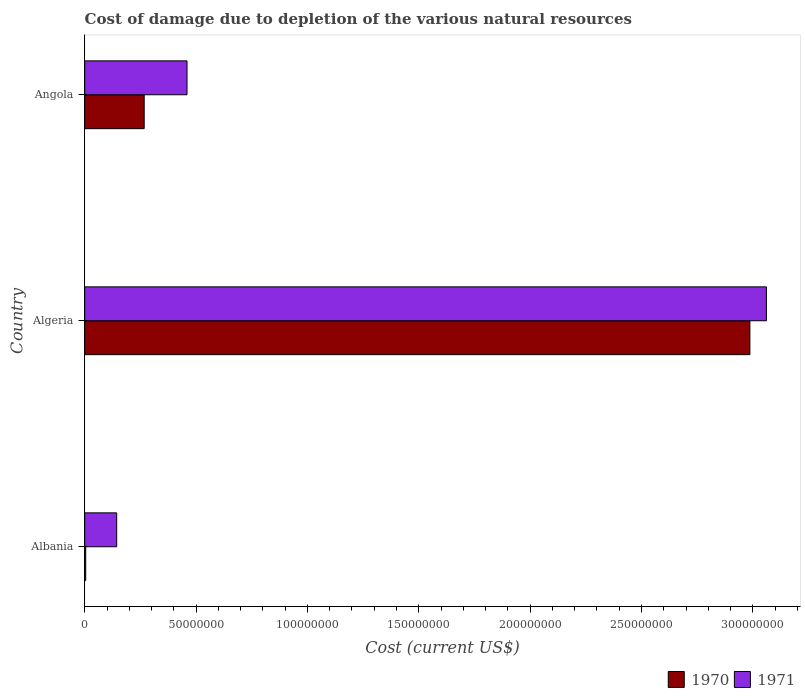How many groups of bars are there?
Your answer should be compact. 3. Are the number of bars per tick equal to the number of legend labels?
Give a very brief answer. Yes. What is the label of the 2nd group of bars from the top?
Ensure brevity in your answer.  Algeria. In how many cases, is the number of bars for a given country not equal to the number of legend labels?
Provide a succinct answer. 0. What is the cost of damage caused due to the depletion of various natural resources in 1970 in Angola?
Your response must be concise. 2.67e+07. Across all countries, what is the maximum cost of damage caused due to the depletion of various natural resources in 1970?
Your answer should be compact. 2.99e+08. Across all countries, what is the minimum cost of damage caused due to the depletion of various natural resources in 1971?
Provide a succinct answer. 1.44e+07. In which country was the cost of damage caused due to the depletion of various natural resources in 1970 maximum?
Ensure brevity in your answer.  Algeria. In which country was the cost of damage caused due to the depletion of various natural resources in 1971 minimum?
Give a very brief answer. Albania. What is the total cost of damage caused due to the depletion of various natural resources in 1971 in the graph?
Offer a very short reply. 3.66e+08. What is the difference between the cost of damage caused due to the depletion of various natural resources in 1970 in Algeria and that in Angola?
Give a very brief answer. 2.72e+08. What is the difference between the cost of damage caused due to the depletion of various natural resources in 1970 in Angola and the cost of damage caused due to the depletion of various natural resources in 1971 in Algeria?
Make the answer very short. -2.79e+08. What is the average cost of damage caused due to the depletion of various natural resources in 1971 per country?
Offer a very short reply. 1.22e+08. What is the difference between the cost of damage caused due to the depletion of various natural resources in 1970 and cost of damage caused due to the depletion of various natural resources in 1971 in Algeria?
Offer a terse response. -7.42e+06. In how many countries, is the cost of damage caused due to the depletion of various natural resources in 1970 greater than 170000000 US$?
Offer a very short reply. 1. What is the ratio of the cost of damage caused due to the depletion of various natural resources in 1970 in Albania to that in Angola?
Make the answer very short. 0.02. Is the cost of damage caused due to the depletion of various natural resources in 1970 in Albania less than that in Angola?
Your response must be concise. Yes. What is the difference between the highest and the second highest cost of damage caused due to the depletion of various natural resources in 1971?
Provide a short and direct response. 2.60e+08. What is the difference between the highest and the lowest cost of damage caused due to the depletion of various natural resources in 1971?
Provide a short and direct response. 2.92e+08. In how many countries, is the cost of damage caused due to the depletion of various natural resources in 1970 greater than the average cost of damage caused due to the depletion of various natural resources in 1970 taken over all countries?
Offer a very short reply. 1. What does the 2nd bar from the bottom in Angola represents?
Make the answer very short. 1971. Are all the bars in the graph horizontal?
Your answer should be very brief. Yes. How many countries are there in the graph?
Provide a succinct answer. 3. What is the difference between two consecutive major ticks on the X-axis?
Your answer should be compact. 5.00e+07. Does the graph contain any zero values?
Provide a short and direct response. No. Does the graph contain grids?
Provide a succinct answer. No. Where does the legend appear in the graph?
Your answer should be compact. Bottom right. What is the title of the graph?
Provide a short and direct response. Cost of damage due to depletion of the various natural resources. Does "2011" appear as one of the legend labels in the graph?
Ensure brevity in your answer.  No. What is the label or title of the X-axis?
Give a very brief answer. Cost (current US$). What is the Cost (current US$) in 1970 in Albania?
Keep it short and to the point. 4.39e+05. What is the Cost (current US$) of 1971 in Albania?
Your response must be concise. 1.44e+07. What is the Cost (current US$) in 1970 in Algeria?
Offer a terse response. 2.99e+08. What is the Cost (current US$) in 1971 in Algeria?
Offer a very short reply. 3.06e+08. What is the Cost (current US$) in 1970 in Angola?
Ensure brevity in your answer.  2.67e+07. What is the Cost (current US$) in 1971 in Angola?
Keep it short and to the point. 4.59e+07. Across all countries, what is the maximum Cost (current US$) of 1970?
Provide a short and direct response. 2.99e+08. Across all countries, what is the maximum Cost (current US$) of 1971?
Offer a very short reply. 3.06e+08. Across all countries, what is the minimum Cost (current US$) of 1970?
Make the answer very short. 4.39e+05. Across all countries, what is the minimum Cost (current US$) of 1971?
Give a very brief answer. 1.44e+07. What is the total Cost (current US$) of 1970 in the graph?
Give a very brief answer. 3.26e+08. What is the total Cost (current US$) in 1971 in the graph?
Provide a succinct answer. 3.66e+08. What is the difference between the Cost (current US$) of 1970 in Albania and that in Algeria?
Offer a terse response. -2.98e+08. What is the difference between the Cost (current US$) of 1971 in Albania and that in Algeria?
Ensure brevity in your answer.  -2.92e+08. What is the difference between the Cost (current US$) in 1970 in Albania and that in Angola?
Offer a terse response. -2.63e+07. What is the difference between the Cost (current US$) in 1971 in Albania and that in Angola?
Provide a short and direct response. -3.16e+07. What is the difference between the Cost (current US$) of 1970 in Algeria and that in Angola?
Your answer should be very brief. 2.72e+08. What is the difference between the Cost (current US$) of 1971 in Algeria and that in Angola?
Give a very brief answer. 2.60e+08. What is the difference between the Cost (current US$) in 1970 in Albania and the Cost (current US$) in 1971 in Algeria?
Make the answer very short. -3.06e+08. What is the difference between the Cost (current US$) in 1970 in Albania and the Cost (current US$) in 1971 in Angola?
Keep it short and to the point. -4.55e+07. What is the difference between the Cost (current US$) in 1970 in Algeria and the Cost (current US$) in 1971 in Angola?
Keep it short and to the point. 2.53e+08. What is the average Cost (current US$) of 1970 per country?
Make the answer very short. 1.09e+08. What is the average Cost (current US$) in 1971 per country?
Provide a short and direct response. 1.22e+08. What is the difference between the Cost (current US$) in 1970 and Cost (current US$) in 1971 in Albania?
Your answer should be very brief. -1.39e+07. What is the difference between the Cost (current US$) in 1970 and Cost (current US$) in 1971 in Algeria?
Your answer should be very brief. -7.42e+06. What is the difference between the Cost (current US$) in 1970 and Cost (current US$) in 1971 in Angola?
Your answer should be very brief. -1.92e+07. What is the ratio of the Cost (current US$) of 1970 in Albania to that in Algeria?
Your response must be concise. 0. What is the ratio of the Cost (current US$) of 1971 in Albania to that in Algeria?
Provide a short and direct response. 0.05. What is the ratio of the Cost (current US$) of 1970 in Albania to that in Angola?
Give a very brief answer. 0.02. What is the ratio of the Cost (current US$) of 1971 in Albania to that in Angola?
Provide a short and direct response. 0.31. What is the ratio of the Cost (current US$) of 1970 in Algeria to that in Angola?
Keep it short and to the point. 11.19. What is the ratio of the Cost (current US$) of 1971 in Algeria to that in Angola?
Make the answer very short. 6.66. What is the difference between the highest and the second highest Cost (current US$) of 1970?
Offer a very short reply. 2.72e+08. What is the difference between the highest and the second highest Cost (current US$) in 1971?
Give a very brief answer. 2.60e+08. What is the difference between the highest and the lowest Cost (current US$) in 1970?
Offer a very short reply. 2.98e+08. What is the difference between the highest and the lowest Cost (current US$) of 1971?
Your response must be concise. 2.92e+08. 